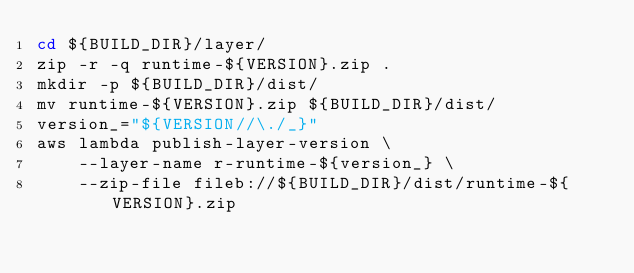<code> <loc_0><loc_0><loc_500><loc_500><_Bash_>cd ${BUILD_DIR}/layer/
zip -r -q runtime-${VERSION}.zip .
mkdir -p ${BUILD_DIR}/dist/
mv runtime-${VERSION}.zip ${BUILD_DIR}/dist/
version_="${VERSION//\./_}"
aws lambda publish-layer-version \
    --layer-name r-runtime-${version_} \
    --zip-file fileb://${BUILD_DIR}/dist/runtime-${VERSION}.zip
</code> 